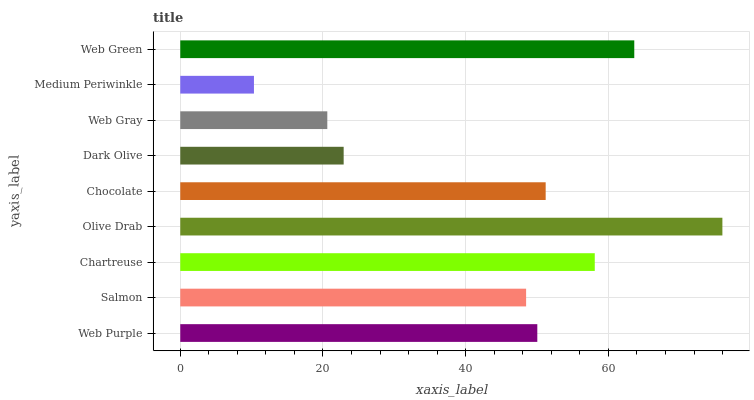Is Medium Periwinkle the minimum?
Answer yes or no. Yes. Is Olive Drab the maximum?
Answer yes or no. Yes. Is Salmon the minimum?
Answer yes or no. No. Is Salmon the maximum?
Answer yes or no. No. Is Web Purple greater than Salmon?
Answer yes or no. Yes. Is Salmon less than Web Purple?
Answer yes or no. Yes. Is Salmon greater than Web Purple?
Answer yes or no. No. Is Web Purple less than Salmon?
Answer yes or no. No. Is Web Purple the high median?
Answer yes or no. Yes. Is Web Purple the low median?
Answer yes or no. Yes. Is Salmon the high median?
Answer yes or no. No. Is Chocolate the low median?
Answer yes or no. No. 